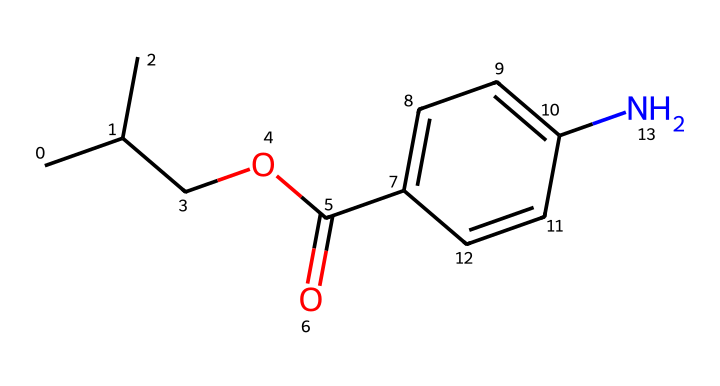How many carbon atoms are present in this chemical? Counting the carbon atoms in the provided SMILES representation, we find a total of 11 carbon atoms (indicated by 'C' in the SMILES).
Answer: 11 What functional group is present in this chemical? The presence of the 'COC(=O)' part indicates that this chemical contains an ester functional group, as the carbonyl (C=O) bonded to an oxygen (O) is characteristic of esters.
Answer: ester What type of drug is indicated by the presence of nitrogen in its structure? The nitrogen atom (N) in the structure suggests that this is an alkaloid, which are often responsible for medicinal properties and psychoactive effects in plants.
Answer: alkaloid How many rings are present in this chemical structure? By examining the structure, there is one aromatic ring denoted by 'C1=CC=C(C=C1)', highlighting it's a cyclic structure with alternating double bonds.
Answer: 1 What is the total number of double bonds in this chemical? Looking at the SMILES, we can identify three double bonds: one in the ester portion between the carbon and oxygen (C=O) and two within the aromatic ring structure (C=C).
Answer: 3 Which part of this chemical indicates its potential use as a remedy derived from flora? The presence of multiple carbon atoms and the nitrogen suggest that it may be derived from plant sources known to produce alkaloid compounds, commonly used for therapeutic purposes.
Answer: alkaloid structure 